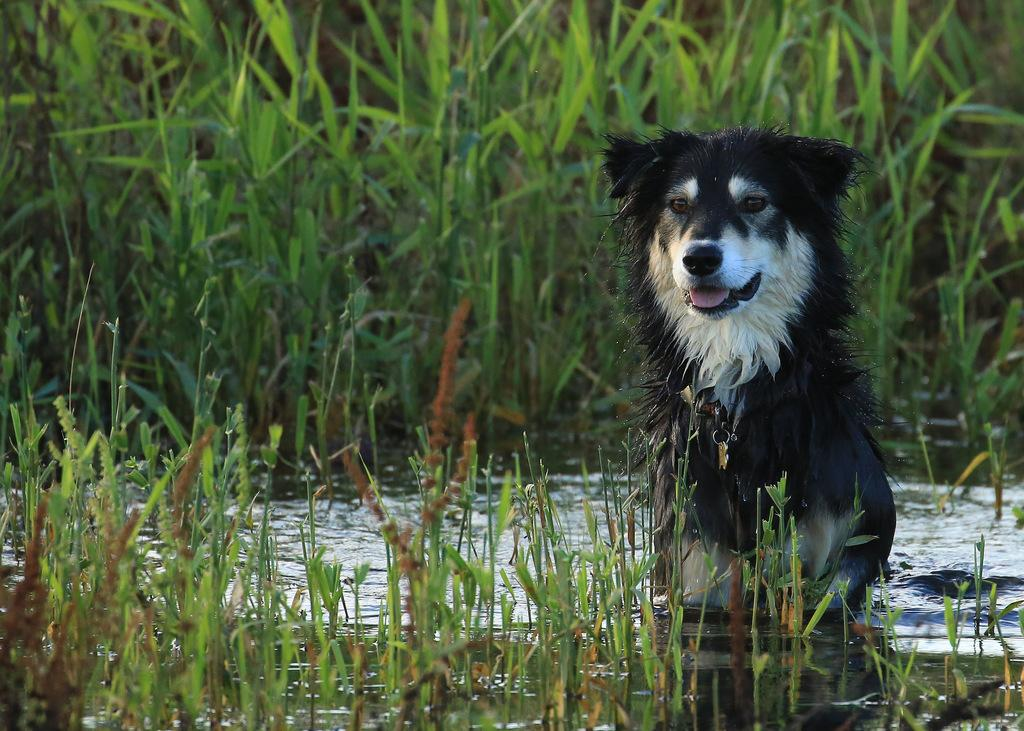What animal is present in the image? There is a dog in the image. Where is the dog located? The dog is in the water. What type of vegetation is around the dog? There is grass around the dog in the image. What type of paper is the dog using to dry off in the image? There is no paper present in the image, and the dog is not shown drying off. 